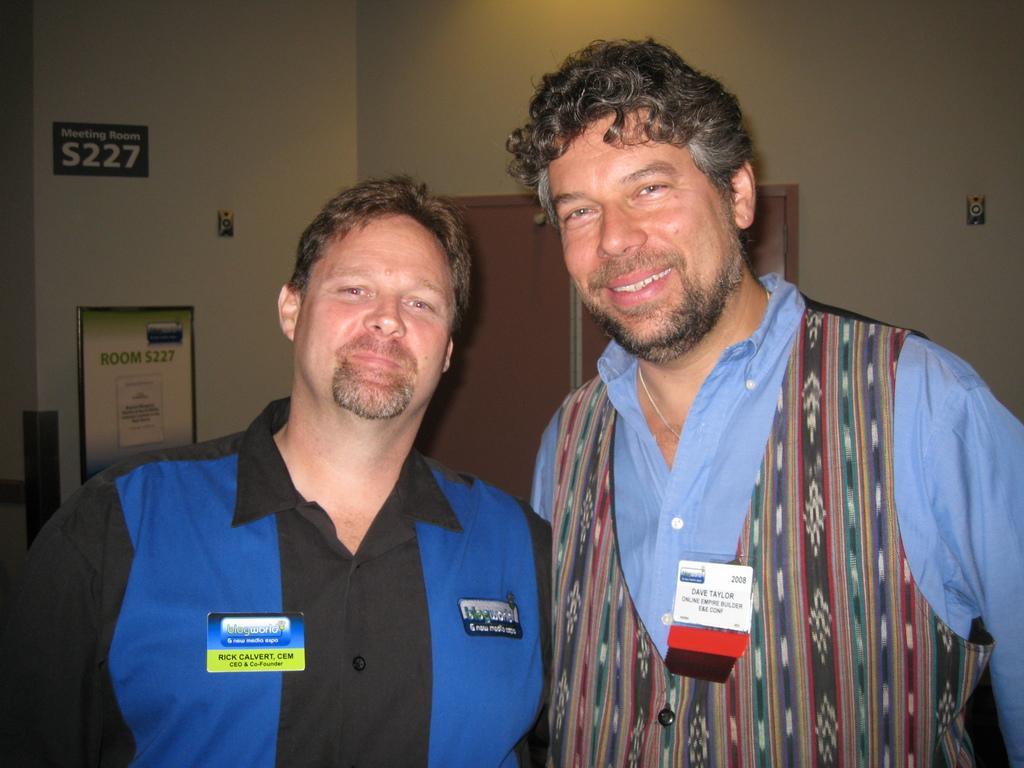Could you give a brief overview of what you see in this image? In this image, we can see two men are seeing and smiling. Background we can see doors, walls, board, stickers, some objects. 